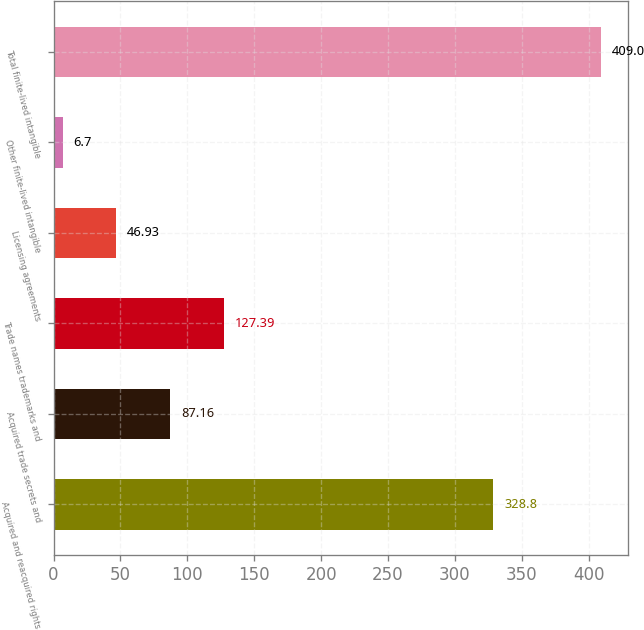Convert chart to OTSL. <chart><loc_0><loc_0><loc_500><loc_500><bar_chart><fcel>Acquired and reacquired rights<fcel>Acquired trade secrets and<fcel>Trade names trademarks and<fcel>Licensing agreements<fcel>Other finite-lived intangible<fcel>Total finite-lived intangible<nl><fcel>328.8<fcel>87.16<fcel>127.39<fcel>46.93<fcel>6.7<fcel>409<nl></chart> 